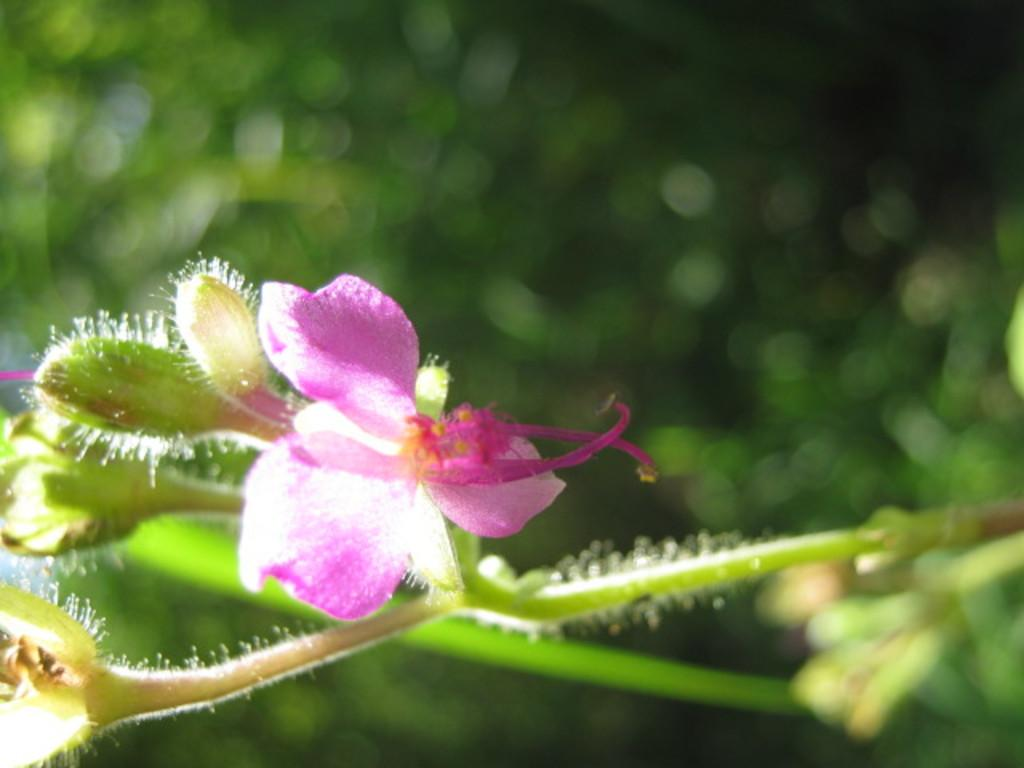What is the main subject of the image? There is a flower in the image. Can you describe any specific features of the flower? There are buds on the stem of the plant. What else can be seen in the image besides the flower? There are other plants visible in the background. What type of cushion is used to support the paper in the image? There is no cushion or paper present in the image; it features a flower with buds on the stem and other plants in the background. 